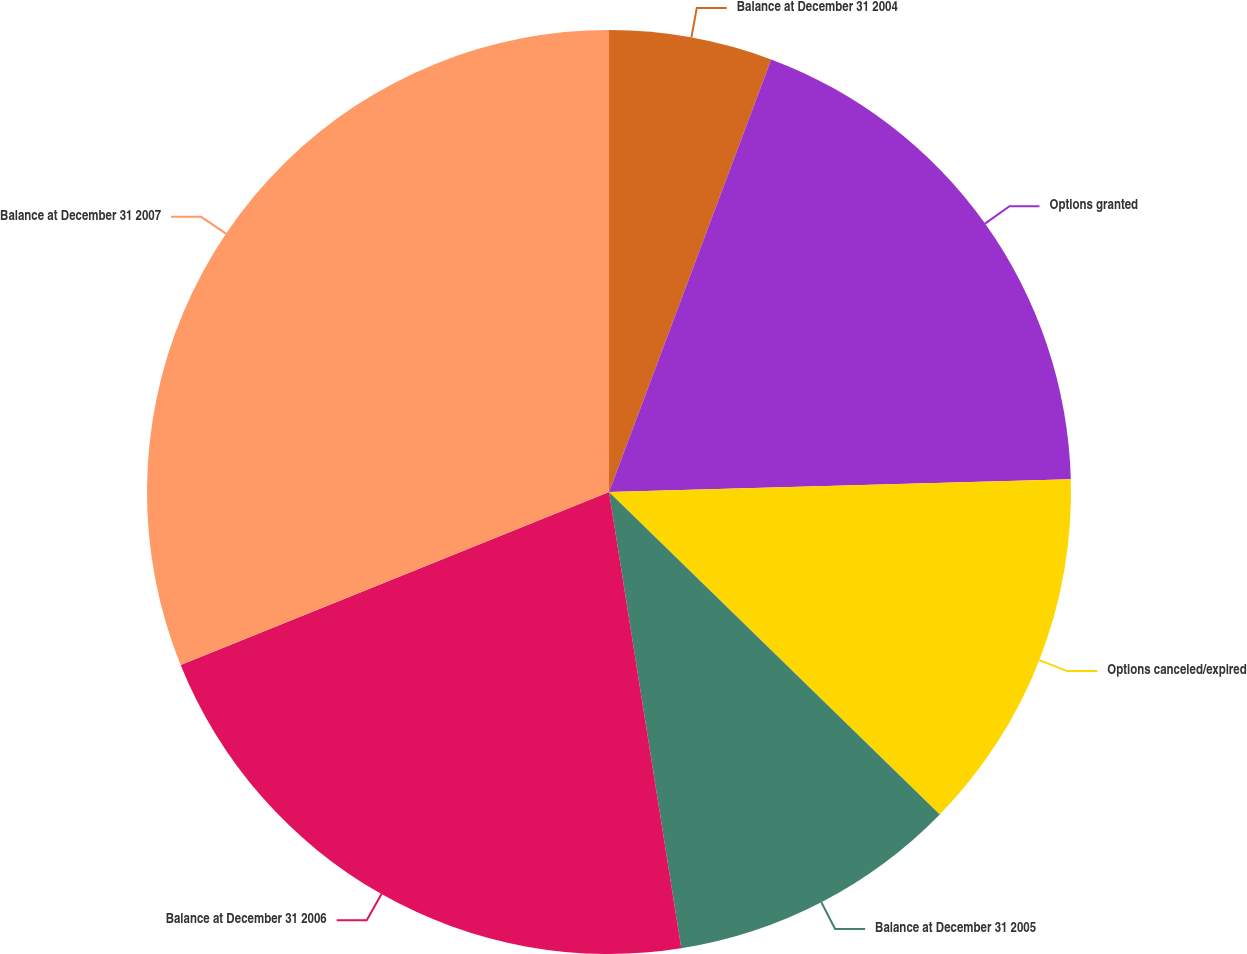<chart> <loc_0><loc_0><loc_500><loc_500><pie_chart><fcel>Balance at December 31 2004<fcel>Options granted<fcel>Options canceled/expired<fcel>Balance at December 31 2005<fcel>Balance at December 31 2006<fcel>Balance at December 31 2007<nl><fcel>5.71%<fcel>18.85%<fcel>12.74%<fcel>10.2%<fcel>21.39%<fcel>31.11%<nl></chart> 